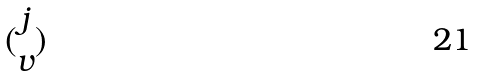<formula> <loc_0><loc_0><loc_500><loc_500>( \begin{matrix} j \\ v \end{matrix} )</formula> 